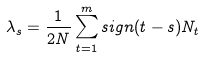Convert formula to latex. <formula><loc_0><loc_0><loc_500><loc_500>\lambda _ { s } = \frac { 1 } { 2 N } \sum _ { t = 1 } ^ { m } s i g n ( t - s ) N _ { t }</formula> 